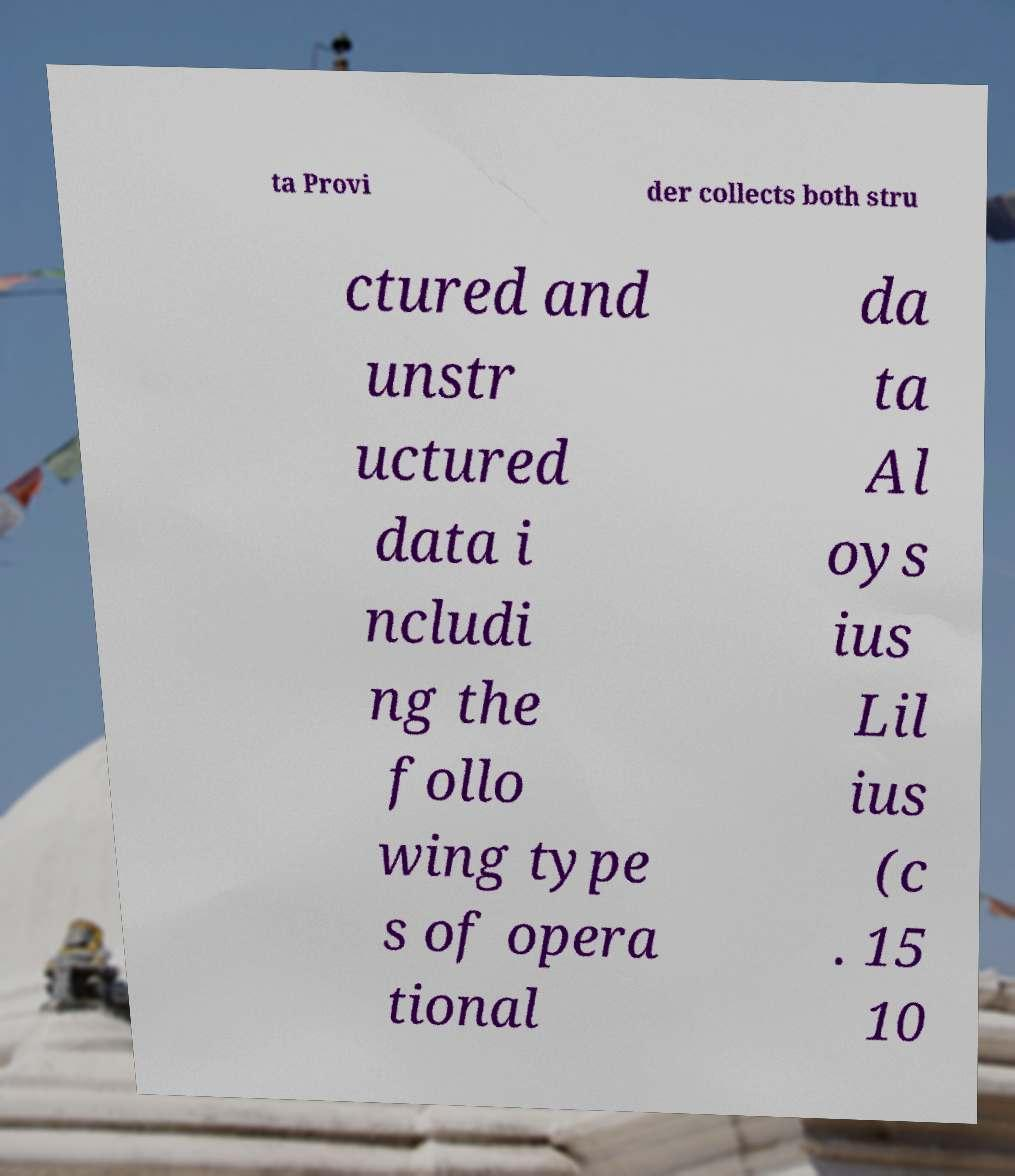Could you assist in decoding the text presented in this image and type it out clearly? ta Provi der collects both stru ctured and unstr uctured data i ncludi ng the follo wing type s of opera tional da ta Al oys ius Lil ius (c . 15 10 